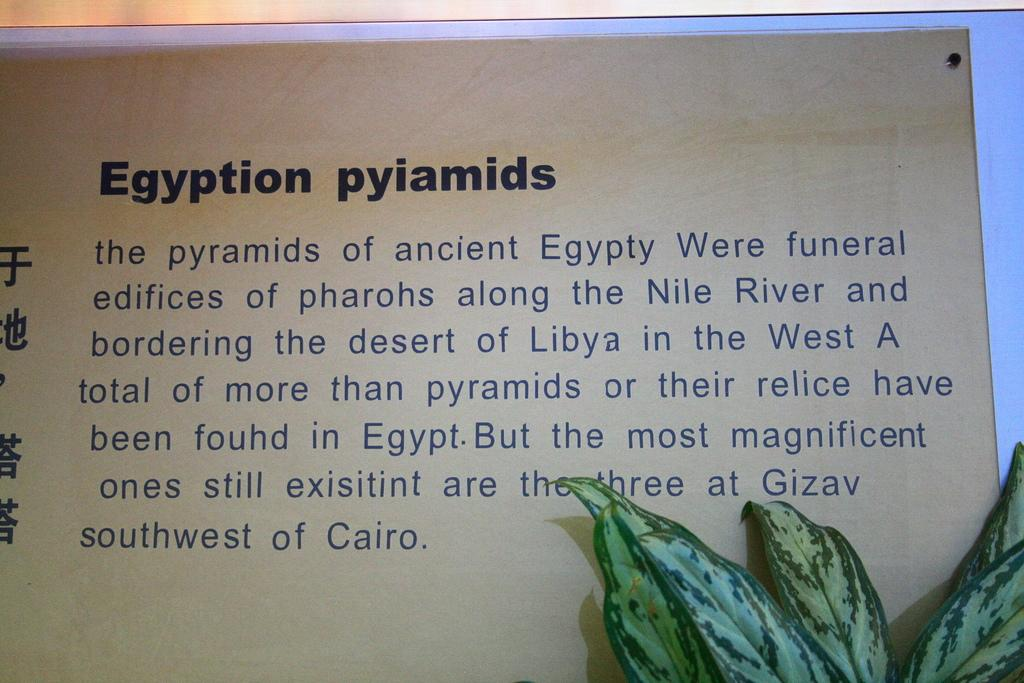<image>
Share a concise interpretation of the image provided. A wall has words printed on it titled Egyption pyiamids, which contains information about Egyptian pyramids 